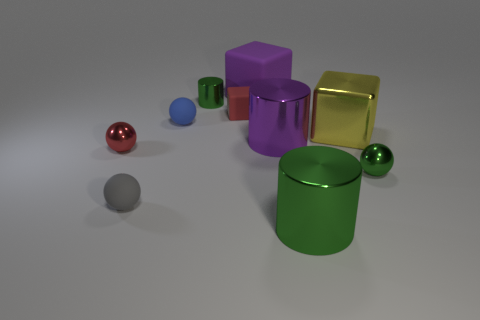The small metal thing that is on the left side of the large yellow metal cube and on the right side of the small red metallic ball is what color?
Your response must be concise. Green. Is the material of the tiny red block the same as the green ball?
Provide a succinct answer. No. The yellow thing has what shape?
Provide a short and direct response. Cube. What number of green shiny cylinders are in front of the small green thing in front of the green object behind the tiny red cube?
Ensure brevity in your answer.  1. What color is the tiny metal thing that is the same shape as the big green metallic thing?
Offer a terse response. Green. What is the shape of the purple matte thing behind the green metallic cylinder that is left of the large purple object behind the small cylinder?
Your answer should be compact. Cube. How big is the green thing that is both in front of the blue thing and on the left side of the big yellow metal object?
Your response must be concise. Large. Are there fewer blue rubber things than red things?
Offer a very short reply. Yes. What is the size of the sphere that is behind the shiny block?
Give a very brief answer. Small. There is a thing that is in front of the small green ball and to the left of the purple rubber object; what shape is it?
Offer a very short reply. Sphere. 